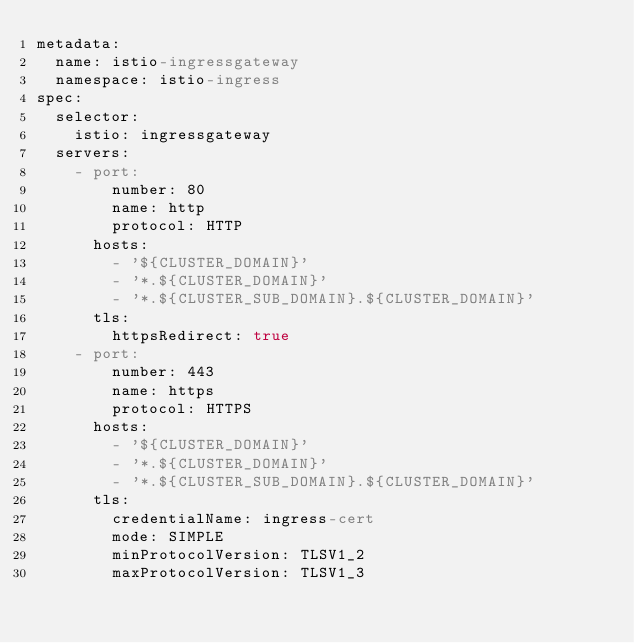<code> <loc_0><loc_0><loc_500><loc_500><_YAML_>metadata:
  name: istio-ingressgateway
  namespace: istio-ingress
spec:
  selector:
    istio: ingressgateway
  servers:
    - port:
        number: 80
        name: http
        protocol: HTTP
      hosts:
        - '${CLUSTER_DOMAIN}'
        - '*.${CLUSTER_DOMAIN}'
        - '*.${CLUSTER_SUB_DOMAIN}.${CLUSTER_DOMAIN}'
      tls:
        httpsRedirect: true
    - port:
        number: 443
        name: https
        protocol: HTTPS
      hosts:
        - '${CLUSTER_DOMAIN}'
        - '*.${CLUSTER_DOMAIN}'
        - '*.${CLUSTER_SUB_DOMAIN}.${CLUSTER_DOMAIN}'
      tls:
        credentialName: ingress-cert
        mode: SIMPLE
        minProtocolVersion: TLSV1_2
        maxProtocolVersion: TLSV1_3
</code> 